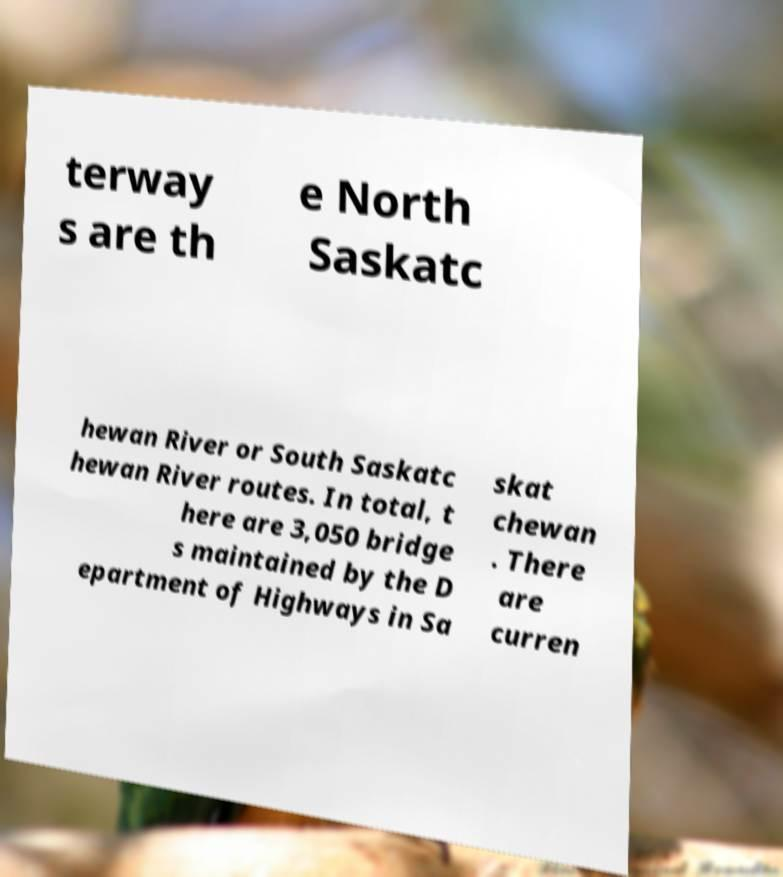Could you extract and type out the text from this image? terway s are th e North Saskatc hewan River or South Saskatc hewan River routes. In total, t here are 3,050 bridge s maintained by the D epartment of Highways in Sa skat chewan . There are curren 